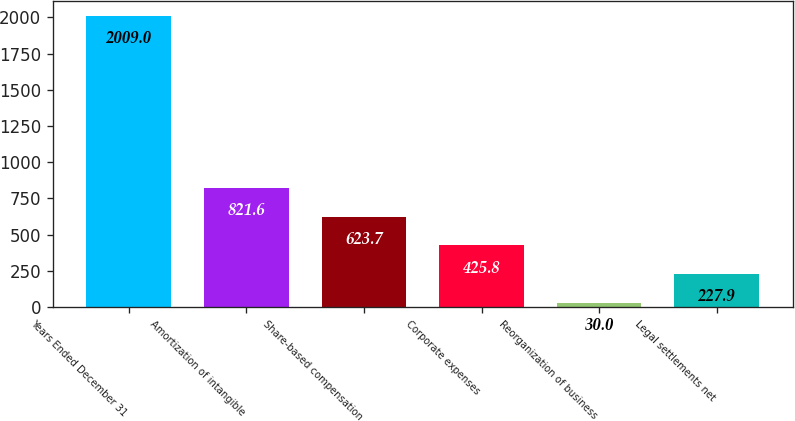<chart> <loc_0><loc_0><loc_500><loc_500><bar_chart><fcel>Years Ended December 31<fcel>Amortization of intangible<fcel>Share-based compensation<fcel>Corporate expenses<fcel>Reorganization of business<fcel>Legal settlements net<nl><fcel>2009<fcel>821.6<fcel>623.7<fcel>425.8<fcel>30<fcel>227.9<nl></chart> 